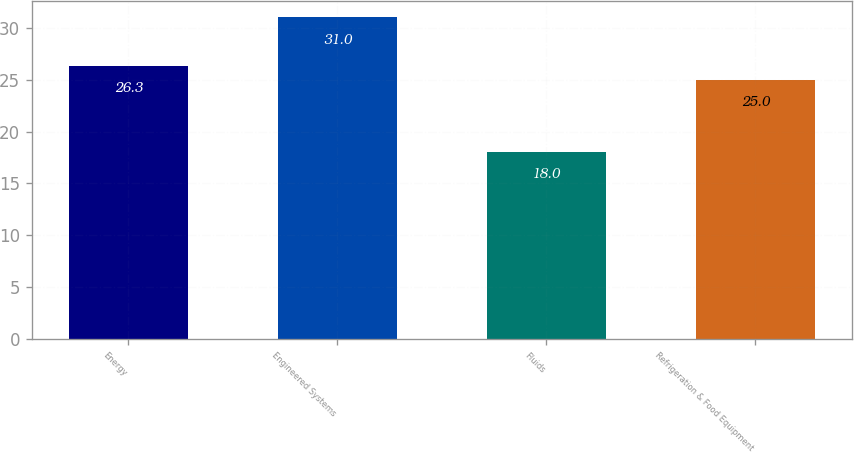Convert chart. <chart><loc_0><loc_0><loc_500><loc_500><bar_chart><fcel>Energy<fcel>Engineered Systems<fcel>Fluids<fcel>Refrigeration & Food Equipment<nl><fcel>26.3<fcel>31<fcel>18<fcel>25<nl></chart> 